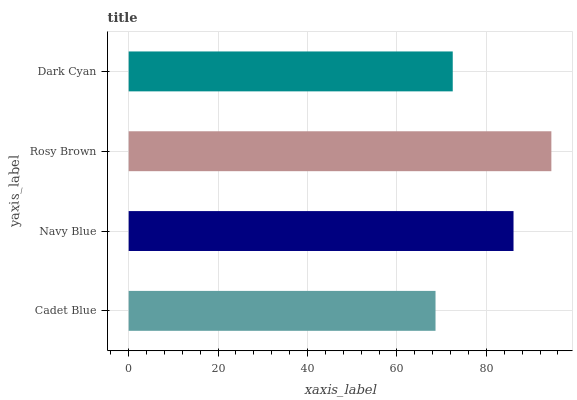Is Cadet Blue the minimum?
Answer yes or no. Yes. Is Rosy Brown the maximum?
Answer yes or no. Yes. Is Navy Blue the minimum?
Answer yes or no. No. Is Navy Blue the maximum?
Answer yes or no. No. Is Navy Blue greater than Cadet Blue?
Answer yes or no. Yes. Is Cadet Blue less than Navy Blue?
Answer yes or no. Yes. Is Cadet Blue greater than Navy Blue?
Answer yes or no. No. Is Navy Blue less than Cadet Blue?
Answer yes or no. No. Is Navy Blue the high median?
Answer yes or no. Yes. Is Dark Cyan the low median?
Answer yes or no. Yes. Is Rosy Brown the high median?
Answer yes or no. No. Is Rosy Brown the low median?
Answer yes or no. No. 